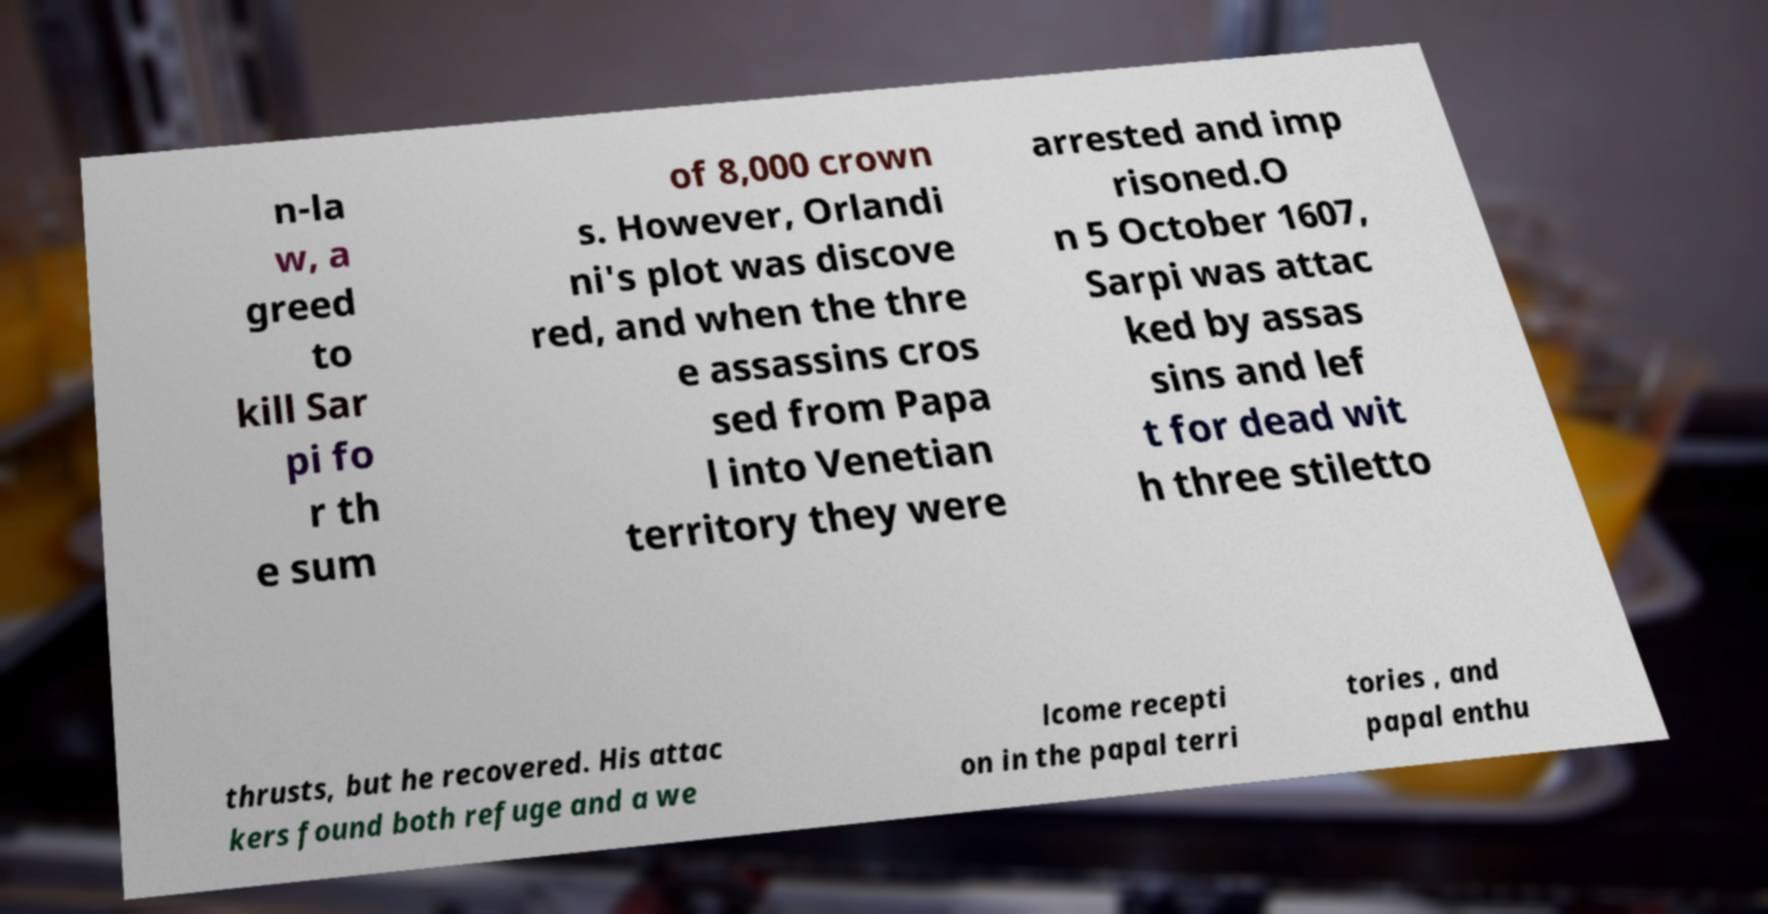Can you accurately transcribe the text from the provided image for me? n-la w, a greed to kill Sar pi fo r th e sum of 8,000 crown s. However, Orlandi ni's plot was discove red, and when the thre e assassins cros sed from Papa l into Venetian territory they were arrested and imp risoned.O n 5 October 1607, Sarpi was attac ked by assas sins and lef t for dead wit h three stiletto thrusts, but he recovered. His attac kers found both refuge and a we lcome recepti on in the papal terri tories , and papal enthu 